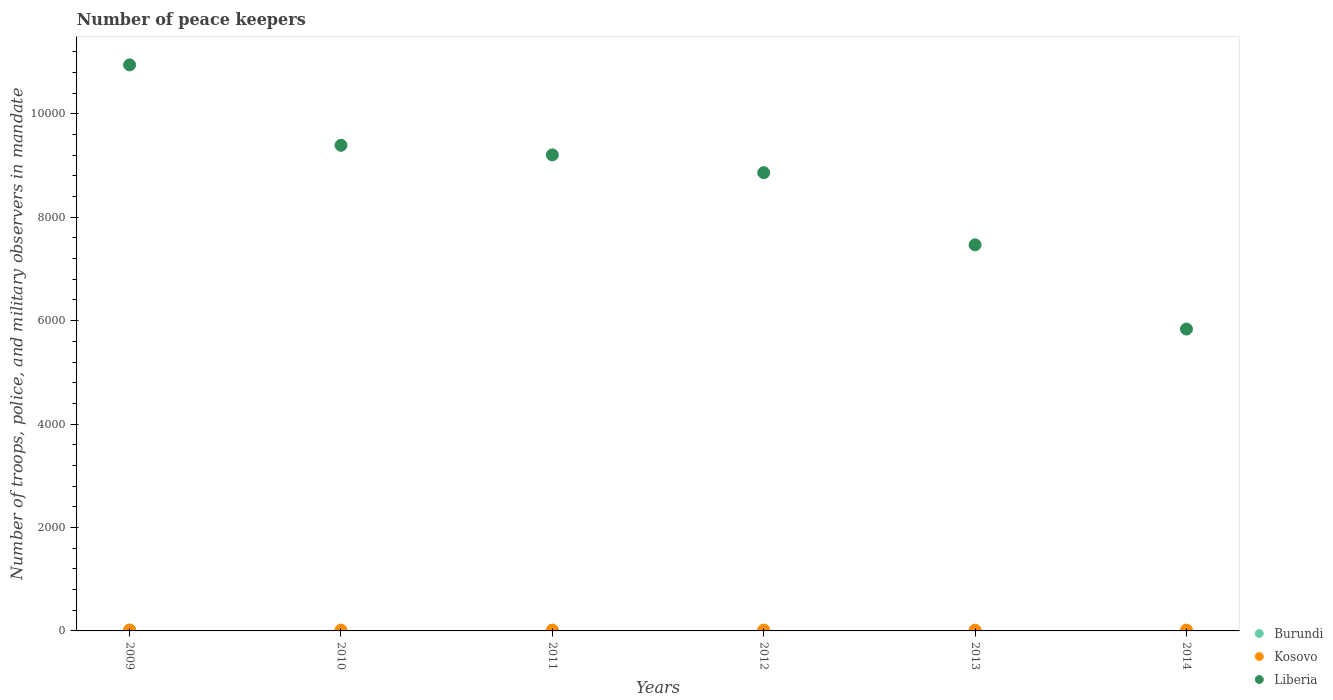What is the number of peace keepers in in Liberia in 2009?
Keep it short and to the point. 1.09e+04. In which year was the number of peace keepers in in Burundi maximum?
Make the answer very short. 2009. What is the total number of peace keepers in in Liberia in the graph?
Give a very brief answer. 5.17e+04. What is the difference between the number of peace keepers in in Kosovo in 2009 and that in 2014?
Your answer should be compact. 1. What is the difference between the number of peace keepers in in Kosovo in 2013 and the number of peace keepers in in Liberia in 2009?
Your response must be concise. -1.09e+04. What is the average number of peace keepers in in Liberia per year?
Keep it short and to the point. 8618.67. What is the ratio of the number of peace keepers in in Kosovo in 2010 to that in 2013?
Offer a terse response. 1.14. Is the number of peace keepers in in Kosovo in 2009 less than that in 2012?
Your answer should be very brief. No. What is the difference between the highest and the second highest number of peace keepers in in Liberia?
Offer a very short reply. 1555. Is the sum of the number of peace keepers in in Burundi in 2009 and 2010 greater than the maximum number of peace keepers in in Kosovo across all years?
Ensure brevity in your answer.  Yes. How many dotlines are there?
Your answer should be very brief. 3. What is the difference between two consecutive major ticks on the Y-axis?
Provide a succinct answer. 2000. Are the values on the major ticks of Y-axis written in scientific E-notation?
Keep it short and to the point. No. Does the graph contain any zero values?
Offer a very short reply. No. Where does the legend appear in the graph?
Give a very brief answer. Bottom right. How many legend labels are there?
Your answer should be compact. 3. How are the legend labels stacked?
Give a very brief answer. Vertical. What is the title of the graph?
Ensure brevity in your answer.  Number of peace keepers. What is the label or title of the Y-axis?
Make the answer very short. Number of troops, police, and military observers in mandate. What is the Number of troops, police, and military observers in mandate of Kosovo in 2009?
Keep it short and to the point. 17. What is the Number of troops, police, and military observers in mandate in Liberia in 2009?
Keep it short and to the point. 1.09e+04. What is the Number of troops, police, and military observers in mandate of Kosovo in 2010?
Your answer should be compact. 16. What is the Number of troops, police, and military observers in mandate of Liberia in 2010?
Give a very brief answer. 9392. What is the Number of troops, police, and military observers in mandate in Kosovo in 2011?
Offer a very short reply. 16. What is the Number of troops, police, and military observers in mandate in Liberia in 2011?
Keep it short and to the point. 9206. What is the Number of troops, police, and military observers in mandate of Burundi in 2012?
Offer a terse response. 2. What is the Number of troops, police, and military observers in mandate in Kosovo in 2012?
Ensure brevity in your answer.  16. What is the Number of troops, police, and military observers in mandate of Liberia in 2012?
Your response must be concise. 8862. What is the Number of troops, police, and military observers in mandate of Burundi in 2013?
Make the answer very short. 2. What is the Number of troops, police, and military observers in mandate in Liberia in 2013?
Provide a succinct answer. 7467. What is the Number of troops, police, and military observers in mandate of Burundi in 2014?
Your answer should be very brief. 2. What is the Number of troops, police, and military observers in mandate of Kosovo in 2014?
Provide a succinct answer. 16. What is the Number of troops, police, and military observers in mandate in Liberia in 2014?
Provide a succinct answer. 5838. Across all years, what is the maximum Number of troops, police, and military observers in mandate in Burundi?
Your answer should be compact. 15. Across all years, what is the maximum Number of troops, police, and military observers in mandate in Kosovo?
Make the answer very short. 17. Across all years, what is the maximum Number of troops, police, and military observers in mandate of Liberia?
Make the answer very short. 1.09e+04. Across all years, what is the minimum Number of troops, police, and military observers in mandate in Liberia?
Provide a succinct answer. 5838. What is the total Number of troops, police, and military observers in mandate in Burundi in the graph?
Make the answer very short. 26. What is the total Number of troops, police, and military observers in mandate in Liberia in the graph?
Offer a very short reply. 5.17e+04. What is the difference between the Number of troops, police, and military observers in mandate in Burundi in 2009 and that in 2010?
Your response must be concise. 11. What is the difference between the Number of troops, police, and military observers in mandate in Kosovo in 2009 and that in 2010?
Your answer should be very brief. 1. What is the difference between the Number of troops, police, and military observers in mandate in Liberia in 2009 and that in 2010?
Your response must be concise. 1555. What is the difference between the Number of troops, police, and military observers in mandate in Kosovo in 2009 and that in 2011?
Provide a short and direct response. 1. What is the difference between the Number of troops, police, and military observers in mandate in Liberia in 2009 and that in 2011?
Keep it short and to the point. 1741. What is the difference between the Number of troops, police, and military observers in mandate of Burundi in 2009 and that in 2012?
Give a very brief answer. 13. What is the difference between the Number of troops, police, and military observers in mandate of Kosovo in 2009 and that in 2012?
Provide a short and direct response. 1. What is the difference between the Number of troops, police, and military observers in mandate of Liberia in 2009 and that in 2012?
Make the answer very short. 2085. What is the difference between the Number of troops, police, and military observers in mandate of Burundi in 2009 and that in 2013?
Provide a succinct answer. 13. What is the difference between the Number of troops, police, and military observers in mandate of Kosovo in 2009 and that in 2013?
Provide a succinct answer. 3. What is the difference between the Number of troops, police, and military observers in mandate in Liberia in 2009 and that in 2013?
Make the answer very short. 3480. What is the difference between the Number of troops, police, and military observers in mandate in Burundi in 2009 and that in 2014?
Give a very brief answer. 13. What is the difference between the Number of troops, police, and military observers in mandate of Liberia in 2009 and that in 2014?
Ensure brevity in your answer.  5109. What is the difference between the Number of troops, police, and military observers in mandate of Kosovo in 2010 and that in 2011?
Your answer should be compact. 0. What is the difference between the Number of troops, police, and military observers in mandate in Liberia in 2010 and that in 2011?
Make the answer very short. 186. What is the difference between the Number of troops, police, and military observers in mandate of Burundi in 2010 and that in 2012?
Keep it short and to the point. 2. What is the difference between the Number of troops, police, and military observers in mandate of Kosovo in 2010 and that in 2012?
Give a very brief answer. 0. What is the difference between the Number of troops, police, and military observers in mandate in Liberia in 2010 and that in 2012?
Offer a very short reply. 530. What is the difference between the Number of troops, police, and military observers in mandate in Kosovo in 2010 and that in 2013?
Keep it short and to the point. 2. What is the difference between the Number of troops, police, and military observers in mandate in Liberia in 2010 and that in 2013?
Provide a short and direct response. 1925. What is the difference between the Number of troops, police, and military observers in mandate in Kosovo in 2010 and that in 2014?
Ensure brevity in your answer.  0. What is the difference between the Number of troops, police, and military observers in mandate in Liberia in 2010 and that in 2014?
Provide a short and direct response. 3554. What is the difference between the Number of troops, police, and military observers in mandate in Burundi in 2011 and that in 2012?
Keep it short and to the point. -1. What is the difference between the Number of troops, police, and military observers in mandate of Kosovo in 2011 and that in 2012?
Your answer should be compact. 0. What is the difference between the Number of troops, police, and military observers in mandate in Liberia in 2011 and that in 2012?
Your response must be concise. 344. What is the difference between the Number of troops, police, and military observers in mandate in Burundi in 2011 and that in 2013?
Provide a short and direct response. -1. What is the difference between the Number of troops, police, and military observers in mandate of Kosovo in 2011 and that in 2013?
Keep it short and to the point. 2. What is the difference between the Number of troops, police, and military observers in mandate in Liberia in 2011 and that in 2013?
Ensure brevity in your answer.  1739. What is the difference between the Number of troops, police, and military observers in mandate of Burundi in 2011 and that in 2014?
Provide a short and direct response. -1. What is the difference between the Number of troops, police, and military observers in mandate in Kosovo in 2011 and that in 2014?
Your answer should be compact. 0. What is the difference between the Number of troops, police, and military observers in mandate of Liberia in 2011 and that in 2014?
Ensure brevity in your answer.  3368. What is the difference between the Number of troops, police, and military observers in mandate of Liberia in 2012 and that in 2013?
Keep it short and to the point. 1395. What is the difference between the Number of troops, police, and military observers in mandate of Burundi in 2012 and that in 2014?
Your answer should be very brief. 0. What is the difference between the Number of troops, police, and military observers in mandate in Kosovo in 2012 and that in 2014?
Ensure brevity in your answer.  0. What is the difference between the Number of troops, police, and military observers in mandate of Liberia in 2012 and that in 2014?
Make the answer very short. 3024. What is the difference between the Number of troops, police, and military observers in mandate of Liberia in 2013 and that in 2014?
Offer a terse response. 1629. What is the difference between the Number of troops, police, and military observers in mandate of Burundi in 2009 and the Number of troops, police, and military observers in mandate of Kosovo in 2010?
Provide a short and direct response. -1. What is the difference between the Number of troops, police, and military observers in mandate of Burundi in 2009 and the Number of troops, police, and military observers in mandate of Liberia in 2010?
Give a very brief answer. -9377. What is the difference between the Number of troops, police, and military observers in mandate of Kosovo in 2009 and the Number of troops, police, and military observers in mandate of Liberia in 2010?
Your answer should be very brief. -9375. What is the difference between the Number of troops, police, and military observers in mandate of Burundi in 2009 and the Number of troops, police, and military observers in mandate of Kosovo in 2011?
Your response must be concise. -1. What is the difference between the Number of troops, police, and military observers in mandate in Burundi in 2009 and the Number of troops, police, and military observers in mandate in Liberia in 2011?
Your answer should be very brief. -9191. What is the difference between the Number of troops, police, and military observers in mandate of Kosovo in 2009 and the Number of troops, police, and military observers in mandate of Liberia in 2011?
Give a very brief answer. -9189. What is the difference between the Number of troops, police, and military observers in mandate in Burundi in 2009 and the Number of troops, police, and military observers in mandate in Liberia in 2012?
Make the answer very short. -8847. What is the difference between the Number of troops, police, and military observers in mandate of Kosovo in 2009 and the Number of troops, police, and military observers in mandate of Liberia in 2012?
Your answer should be very brief. -8845. What is the difference between the Number of troops, police, and military observers in mandate of Burundi in 2009 and the Number of troops, police, and military observers in mandate of Kosovo in 2013?
Make the answer very short. 1. What is the difference between the Number of troops, police, and military observers in mandate of Burundi in 2009 and the Number of troops, police, and military observers in mandate of Liberia in 2013?
Your answer should be very brief. -7452. What is the difference between the Number of troops, police, and military observers in mandate in Kosovo in 2009 and the Number of troops, police, and military observers in mandate in Liberia in 2013?
Give a very brief answer. -7450. What is the difference between the Number of troops, police, and military observers in mandate of Burundi in 2009 and the Number of troops, police, and military observers in mandate of Kosovo in 2014?
Provide a succinct answer. -1. What is the difference between the Number of troops, police, and military observers in mandate in Burundi in 2009 and the Number of troops, police, and military observers in mandate in Liberia in 2014?
Provide a succinct answer. -5823. What is the difference between the Number of troops, police, and military observers in mandate in Kosovo in 2009 and the Number of troops, police, and military observers in mandate in Liberia in 2014?
Provide a short and direct response. -5821. What is the difference between the Number of troops, police, and military observers in mandate in Burundi in 2010 and the Number of troops, police, and military observers in mandate in Kosovo in 2011?
Keep it short and to the point. -12. What is the difference between the Number of troops, police, and military observers in mandate of Burundi in 2010 and the Number of troops, police, and military observers in mandate of Liberia in 2011?
Your answer should be very brief. -9202. What is the difference between the Number of troops, police, and military observers in mandate of Kosovo in 2010 and the Number of troops, police, and military observers in mandate of Liberia in 2011?
Your answer should be very brief. -9190. What is the difference between the Number of troops, police, and military observers in mandate in Burundi in 2010 and the Number of troops, police, and military observers in mandate in Liberia in 2012?
Offer a very short reply. -8858. What is the difference between the Number of troops, police, and military observers in mandate of Kosovo in 2010 and the Number of troops, police, and military observers in mandate of Liberia in 2012?
Offer a terse response. -8846. What is the difference between the Number of troops, police, and military observers in mandate in Burundi in 2010 and the Number of troops, police, and military observers in mandate in Kosovo in 2013?
Keep it short and to the point. -10. What is the difference between the Number of troops, police, and military observers in mandate of Burundi in 2010 and the Number of troops, police, and military observers in mandate of Liberia in 2013?
Provide a succinct answer. -7463. What is the difference between the Number of troops, police, and military observers in mandate of Kosovo in 2010 and the Number of troops, police, and military observers in mandate of Liberia in 2013?
Your response must be concise. -7451. What is the difference between the Number of troops, police, and military observers in mandate in Burundi in 2010 and the Number of troops, police, and military observers in mandate in Liberia in 2014?
Offer a terse response. -5834. What is the difference between the Number of troops, police, and military observers in mandate of Kosovo in 2010 and the Number of troops, police, and military observers in mandate of Liberia in 2014?
Make the answer very short. -5822. What is the difference between the Number of troops, police, and military observers in mandate in Burundi in 2011 and the Number of troops, police, and military observers in mandate in Kosovo in 2012?
Provide a succinct answer. -15. What is the difference between the Number of troops, police, and military observers in mandate of Burundi in 2011 and the Number of troops, police, and military observers in mandate of Liberia in 2012?
Offer a terse response. -8861. What is the difference between the Number of troops, police, and military observers in mandate of Kosovo in 2011 and the Number of troops, police, and military observers in mandate of Liberia in 2012?
Your answer should be compact. -8846. What is the difference between the Number of troops, police, and military observers in mandate of Burundi in 2011 and the Number of troops, police, and military observers in mandate of Kosovo in 2013?
Provide a short and direct response. -13. What is the difference between the Number of troops, police, and military observers in mandate of Burundi in 2011 and the Number of troops, police, and military observers in mandate of Liberia in 2013?
Give a very brief answer. -7466. What is the difference between the Number of troops, police, and military observers in mandate in Kosovo in 2011 and the Number of troops, police, and military observers in mandate in Liberia in 2013?
Offer a very short reply. -7451. What is the difference between the Number of troops, police, and military observers in mandate in Burundi in 2011 and the Number of troops, police, and military observers in mandate in Liberia in 2014?
Keep it short and to the point. -5837. What is the difference between the Number of troops, police, and military observers in mandate of Kosovo in 2011 and the Number of troops, police, and military observers in mandate of Liberia in 2014?
Ensure brevity in your answer.  -5822. What is the difference between the Number of troops, police, and military observers in mandate in Burundi in 2012 and the Number of troops, police, and military observers in mandate in Kosovo in 2013?
Your answer should be compact. -12. What is the difference between the Number of troops, police, and military observers in mandate in Burundi in 2012 and the Number of troops, police, and military observers in mandate in Liberia in 2013?
Provide a succinct answer. -7465. What is the difference between the Number of troops, police, and military observers in mandate of Kosovo in 2012 and the Number of troops, police, and military observers in mandate of Liberia in 2013?
Your answer should be compact. -7451. What is the difference between the Number of troops, police, and military observers in mandate in Burundi in 2012 and the Number of troops, police, and military observers in mandate in Liberia in 2014?
Offer a terse response. -5836. What is the difference between the Number of troops, police, and military observers in mandate in Kosovo in 2012 and the Number of troops, police, and military observers in mandate in Liberia in 2014?
Your response must be concise. -5822. What is the difference between the Number of troops, police, and military observers in mandate of Burundi in 2013 and the Number of troops, police, and military observers in mandate of Liberia in 2014?
Provide a short and direct response. -5836. What is the difference between the Number of troops, police, and military observers in mandate in Kosovo in 2013 and the Number of troops, police, and military observers in mandate in Liberia in 2014?
Your answer should be compact. -5824. What is the average Number of troops, police, and military observers in mandate in Burundi per year?
Ensure brevity in your answer.  4.33. What is the average Number of troops, police, and military observers in mandate in Kosovo per year?
Offer a very short reply. 15.83. What is the average Number of troops, police, and military observers in mandate in Liberia per year?
Your response must be concise. 8618.67. In the year 2009, what is the difference between the Number of troops, police, and military observers in mandate in Burundi and Number of troops, police, and military observers in mandate in Liberia?
Your answer should be compact. -1.09e+04. In the year 2009, what is the difference between the Number of troops, police, and military observers in mandate in Kosovo and Number of troops, police, and military observers in mandate in Liberia?
Provide a succinct answer. -1.09e+04. In the year 2010, what is the difference between the Number of troops, police, and military observers in mandate of Burundi and Number of troops, police, and military observers in mandate of Kosovo?
Your answer should be very brief. -12. In the year 2010, what is the difference between the Number of troops, police, and military observers in mandate of Burundi and Number of troops, police, and military observers in mandate of Liberia?
Your answer should be compact. -9388. In the year 2010, what is the difference between the Number of troops, police, and military observers in mandate in Kosovo and Number of troops, police, and military observers in mandate in Liberia?
Ensure brevity in your answer.  -9376. In the year 2011, what is the difference between the Number of troops, police, and military observers in mandate in Burundi and Number of troops, police, and military observers in mandate in Liberia?
Your answer should be very brief. -9205. In the year 2011, what is the difference between the Number of troops, police, and military observers in mandate of Kosovo and Number of troops, police, and military observers in mandate of Liberia?
Keep it short and to the point. -9190. In the year 2012, what is the difference between the Number of troops, police, and military observers in mandate of Burundi and Number of troops, police, and military observers in mandate of Kosovo?
Keep it short and to the point. -14. In the year 2012, what is the difference between the Number of troops, police, and military observers in mandate of Burundi and Number of troops, police, and military observers in mandate of Liberia?
Provide a succinct answer. -8860. In the year 2012, what is the difference between the Number of troops, police, and military observers in mandate of Kosovo and Number of troops, police, and military observers in mandate of Liberia?
Ensure brevity in your answer.  -8846. In the year 2013, what is the difference between the Number of troops, police, and military observers in mandate of Burundi and Number of troops, police, and military observers in mandate of Kosovo?
Your response must be concise. -12. In the year 2013, what is the difference between the Number of troops, police, and military observers in mandate in Burundi and Number of troops, police, and military observers in mandate in Liberia?
Offer a very short reply. -7465. In the year 2013, what is the difference between the Number of troops, police, and military observers in mandate in Kosovo and Number of troops, police, and military observers in mandate in Liberia?
Keep it short and to the point. -7453. In the year 2014, what is the difference between the Number of troops, police, and military observers in mandate in Burundi and Number of troops, police, and military observers in mandate in Kosovo?
Make the answer very short. -14. In the year 2014, what is the difference between the Number of troops, police, and military observers in mandate in Burundi and Number of troops, police, and military observers in mandate in Liberia?
Keep it short and to the point. -5836. In the year 2014, what is the difference between the Number of troops, police, and military observers in mandate of Kosovo and Number of troops, police, and military observers in mandate of Liberia?
Your response must be concise. -5822. What is the ratio of the Number of troops, police, and military observers in mandate of Burundi in 2009 to that in 2010?
Your answer should be very brief. 3.75. What is the ratio of the Number of troops, police, and military observers in mandate in Kosovo in 2009 to that in 2010?
Give a very brief answer. 1.06. What is the ratio of the Number of troops, police, and military observers in mandate of Liberia in 2009 to that in 2010?
Offer a very short reply. 1.17. What is the ratio of the Number of troops, police, and military observers in mandate in Kosovo in 2009 to that in 2011?
Provide a short and direct response. 1.06. What is the ratio of the Number of troops, police, and military observers in mandate in Liberia in 2009 to that in 2011?
Provide a succinct answer. 1.19. What is the ratio of the Number of troops, police, and military observers in mandate in Kosovo in 2009 to that in 2012?
Make the answer very short. 1.06. What is the ratio of the Number of troops, police, and military observers in mandate in Liberia in 2009 to that in 2012?
Provide a succinct answer. 1.24. What is the ratio of the Number of troops, police, and military observers in mandate in Burundi in 2009 to that in 2013?
Offer a very short reply. 7.5. What is the ratio of the Number of troops, police, and military observers in mandate in Kosovo in 2009 to that in 2013?
Your answer should be compact. 1.21. What is the ratio of the Number of troops, police, and military observers in mandate of Liberia in 2009 to that in 2013?
Provide a succinct answer. 1.47. What is the ratio of the Number of troops, police, and military observers in mandate of Kosovo in 2009 to that in 2014?
Keep it short and to the point. 1.06. What is the ratio of the Number of troops, police, and military observers in mandate in Liberia in 2009 to that in 2014?
Your response must be concise. 1.88. What is the ratio of the Number of troops, police, and military observers in mandate of Burundi in 2010 to that in 2011?
Your response must be concise. 4. What is the ratio of the Number of troops, police, and military observers in mandate in Kosovo in 2010 to that in 2011?
Provide a succinct answer. 1. What is the ratio of the Number of troops, police, and military observers in mandate in Liberia in 2010 to that in 2011?
Offer a terse response. 1.02. What is the ratio of the Number of troops, police, and military observers in mandate of Kosovo in 2010 to that in 2012?
Offer a very short reply. 1. What is the ratio of the Number of troops, police, and military observers in mandate of Liberia in 2010 to that in 2012?
Provide a short and direct response. 1.06. What is the ratio of the Number of troops, police, and military observers in mandate in Burundi in 2010 to that in 2013?
Your answer should be very brief. 2. What is the ratio of the Number of troops, police, and military observers in mandate of Kosovo in 2010 to that in 2013?
Make the answer very short. 1.14. What is the ratio of the Number of troops, police, and military observers in mandate in Liberia in 2010 to that in 2013?
Provide a succinct answer. 1.26. What is the ratio of the Number of troops, police, and military observers in mandate in Liberia in 2010 to that in 2014?
Your answer should be very brief. 1.61. What is the ratio of the Number of troops, police, and military observers in mandate of Burundi in 2011 to that in 2012?
Keep it short and to the point. 0.5. What is the ratio of the Number of troops, police, and military observers in mandate in Liberia in 2011 to that in 2012?
Provide a succinct answer. 1.04. What is the ratio of the Number of troops, police, and military observers in mandate of Burundi in 2011 to that in 2013?
Provide a succinct answer. 0.5. What is the ratio of the Number of troops, police, and military observers in mandate in Kosovo in 2011 to that in 2013?
Offer a very short reply. 1.14. What is the ratio of the Number of troops, police, and military observers in mandate in Liberia in 2011 to that in 2013?
Provide a short and direct response. 1.23. What is the ratio of the Number of troops, police, and military observers in mandate in Kosovo in 2011 to that in 2014?
Your response must be concise. 1. What is the ratio of the Number of troops, police, and military observers in mandate of Liberia in 2011 to that in 2014?
Ensure brevity in your answer.  1.58. What is the ratio of the Number of troops, police, and military observers in mandate in Burundi in 2012 to that in 2013?
Your response must be concise. 1. What is the ratio of the Number of troops, police, and military observers in mandate of Liberia in 2012 to that in 2013?
Ensure brevity in your answer.  1.19. What is the ratio of the Number of troops, police, and military observers in mandate of Kosovo in 2012 to that in 2014?
Keep it short and to the point. 1. What is the ratio of the Number of troops, police, and military observers in mandate of Liberia in 2012 to that in 2014?
Your answer should be compact. 1.52. What is the ratio of the Number of troops, police, and military observers in mandate in Kosovo in 2013 to that in 2014?
Your answer should be compact. 0.88. What is the ratio of the Number of troops, police, and military observers in mandate of Liberia in 2013 to that in 2014?
Offer a very short reply. 1.28. What is the difference between the highest and the second highest Number of troops, police, and military observers in mandate of Kosovo?
Ensure brevity in your answer.  1. What is the difference between the highest and the second highest Number of troops, police, and military observers in mandate of Liberia?
Provide a succinct answer. 1555. What is the difference between the highest and the lowest Number of troops, police, and military observers in mandate of Liberia?
Ensure brevity in your answer.  5109. 